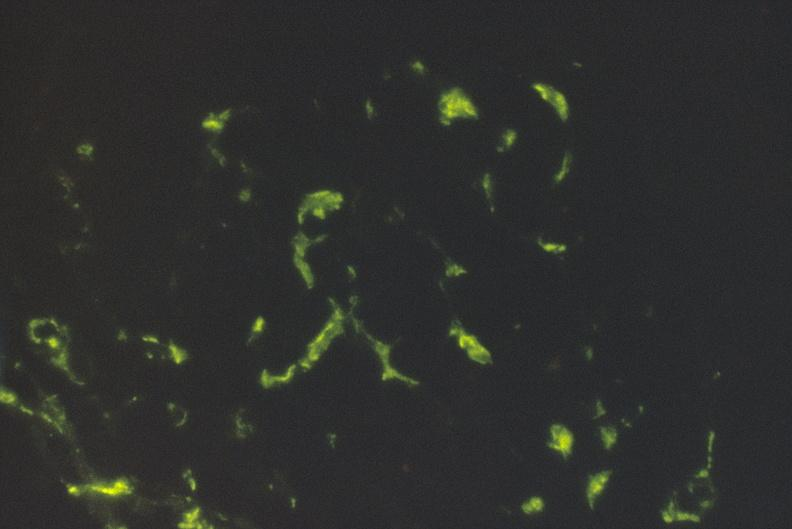s urinary present?
Answer the question using a single word or phrase. Yes 